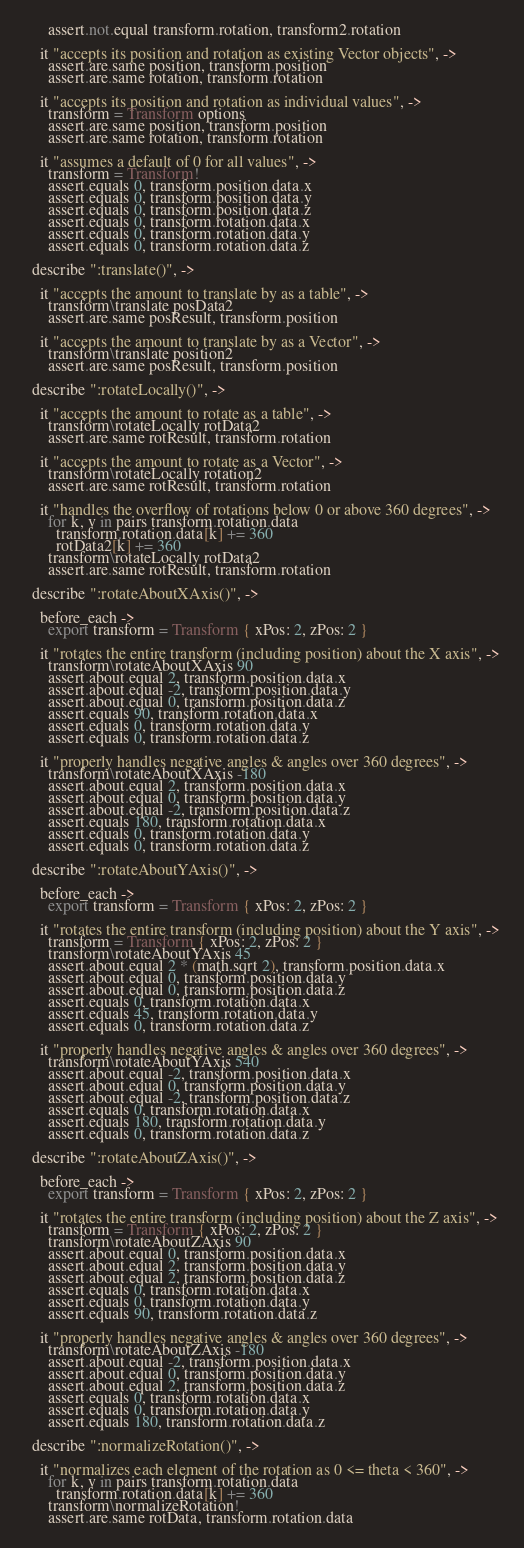<code> <loc_0><loc_0><loc_500><loc_500><_MoonScript_>      assert.not.equal transform.rotation, transform2.rotation

    it "accepts its position and rotation as existing Vector objects", ->
      assert.are.same position, transform.position
      assert.are.same rotation, transform.rotation

    it "accepts its position and rotation as individual values", ->
      transform = Transform options
      assert.are.same position, transform.position
      assert.are.same rotation, transform.rotation

    it "assumes a default of 0 for all values", ->
      transform = Transform!
      assert.equals 0, transform.position.data.x
      assert.equals 0, transform.position.data.y
      assert.equals 0, transform.position.data.z
      assert.equals 0, transform.rotation.data.x
      assert.equals 0, transform.rotation.data.y
      assert.equals 0, transform.rotation.data.z

  describe ":translate()", ->

    it "accepts the amount to translate by as a table", ->
      transform\translate posData2
      assert.are.same posResult, transform.position

    it "accepts the amount to translate by as a Vector", ->
      transform\translate position2
      assert.are.same posResult, transform.position

  describe ":rotateLocally()", ->

    it "accepts the amount to rotate as a table", ->
      transform\rotateLocally rotData2
      assert.are.same rotResult, transform.rotation

    it "accepts the amount to rotate as a Vector", ->
      transform\rotateLocally rotation2
      assert.are.same rotResult, transform.rotation

    it "handles the overflow of rotations below 0 or above 360 degrees", ->
      for k, v in pairs transform.rotation.data
        transform.rotation.data[k] += 360
        rotData2[k] += 360
      transform\rotateLocally rotData2
      assert.are.same rotResult, transform.rotation

  describe ":rotateAboutXAxis()", ->

    before_each ->
      export transform = Transform { xPos: 2, zPos: 2 }

    it "rotates the entire transform (including position) about the X axis", ->
      transform\rotateAboutXAxis 90
      assert.about.equal 2, transform.position.data.x
      assert.about.equal -2, transform.position.data.y
      assert.about.equal 0, transform.position.data.z
      assert.equals 90, transform.rotation.data.x
      assert.equals 0, transform.rotation.data.y
      assert.equals 0, transform.rotation.data.z

    it "properly handles negative angles & angles over 360 degrees", ->
      transform\rotateAboutXAxis -180
      assert.about.equal 2, transform.position.data.x
      assert.about.equal 0, transform.position.data.y
      assert.about.equal -2, transform.position.data.z
      assert.equals 180, transform.rotation.data.x
      assert.equals 0, transform.rotation.data.y
      assert.equals 0, transform.rotation.data.z

  describe ":rotateAboutYAxis()", ->

    before_each ->
      export transform = Transform { xPos: 2, zPos: 2 }

    it "rotates the entire transform (including position) about the Y axis", ->
      transform = Transform { xPos: 2, zPos: 2 }
      transform\rotateAboutYAxis 45
      assert.about.equal 2 * (math.sqrt 2), transform.position.data.x
      assert.about.equal 0, transform.position.data.y
      assert.about.equal 0, transform.position.data.z
      assert.equals 0, transform.rotation.data.x
      assert.equals 45, transform.rotation.data.y
      assert.equals 0, transform.rotation.data.z

    it "properly handles negative angles & angles over 360 degrees", ->
      transform\rotateAboutYAxis 540
      assert.about.equal -2, transform.position.data.x
      assert.about.equal 0, transform.position.data.y
      assert.about.equal -2, transform.position.data.z
      assert.equals 0, transform.rotation.data.x
      assert.equals 180, transform.rotation.data.y
      assert.equals 0, transform.rotation.data.z

  describe ":rotateAboutZAxis()", ->

    before_each ->
      export transform = Transform { xPos: 2, zPos: 2 }

    it "rotates the entire transform (including position) about the Z axis", ->
      transform = Transform { xPos: 2, zPos: 2 }
      transform\rotateAboutZAxis 90
      assert.about.equal 0, transform.position.data.x
      assert.about.equal 2, transform.position.data.y
      assert.about.equal 2, transform.position.data.z
      assert.equals 0, transform.rotation.data.x
      assert.equals 0, transform.rotation.data.y
      assert.equals 90, transform.rotation.data.z

    it "properly handles negative angles & angles over 360 degrees", ->
      transform\rotateAboutZAxis -180
      assert.about.equal -2, transform.position.data.x
      assert.about.equal 0, transform.position.data.y
      assert.about.equal 2, transform.position.data.z
      assert.equals 0, transform.rotation.data.x
      assert.equals 0, transform.rotation.data.y
      assert.equals 180, transform.rotation.data.z

  describe ":normalizeRotation()", ->

    it "normalizes each element of the rotation as 0 <= theta < 360", ->
      for k, v in pairs transform.rotation.data
        transform.rotation.data[k] += 360
      transform\normalizeRotation!
      assert.are.same rotData, transform.rotation.data
</code> 